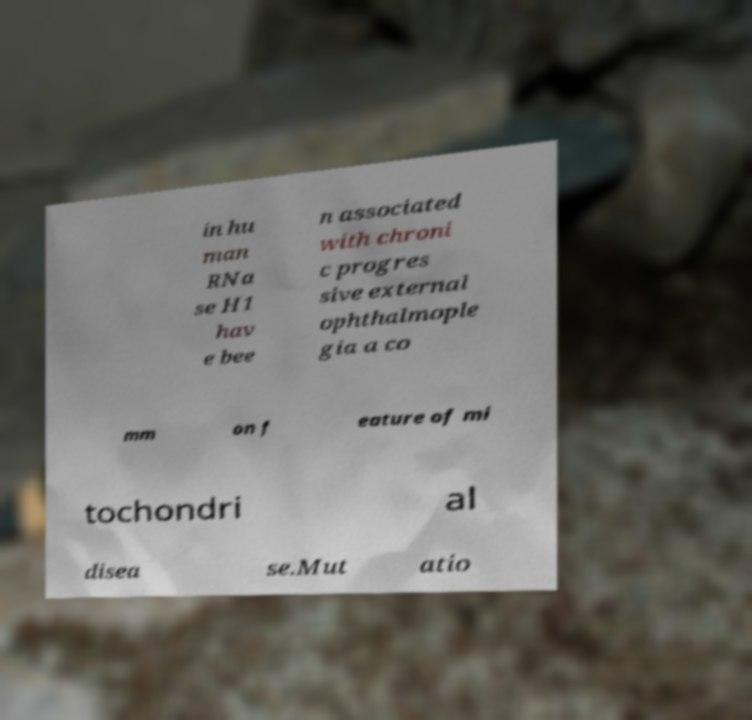Could you extract and type out the text from this image? in hu man RNa se H1 hav e bee n associated with chroni c progres sive external ophthalmople gia a co mm on f eature of mi tochondri al disea se.Mut atio 